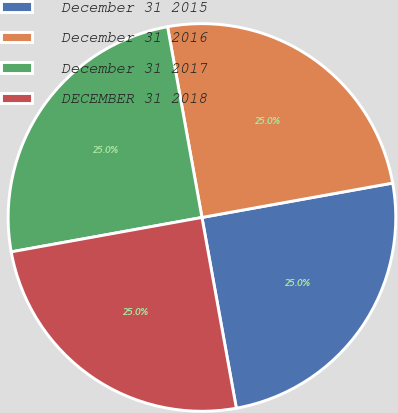Convert chart. <chart><loc_0><loc_0><loc_500><loc_500><pie_chart><fcel>December 31 2015<fcel>December 31 2016<fcel>December 31 2017<fcel>DECEMBER 31 2018<nl><fcel>25.0%<fcel>25.0%<fcel>25.0%<fcel>25.0%<nl></chart> 